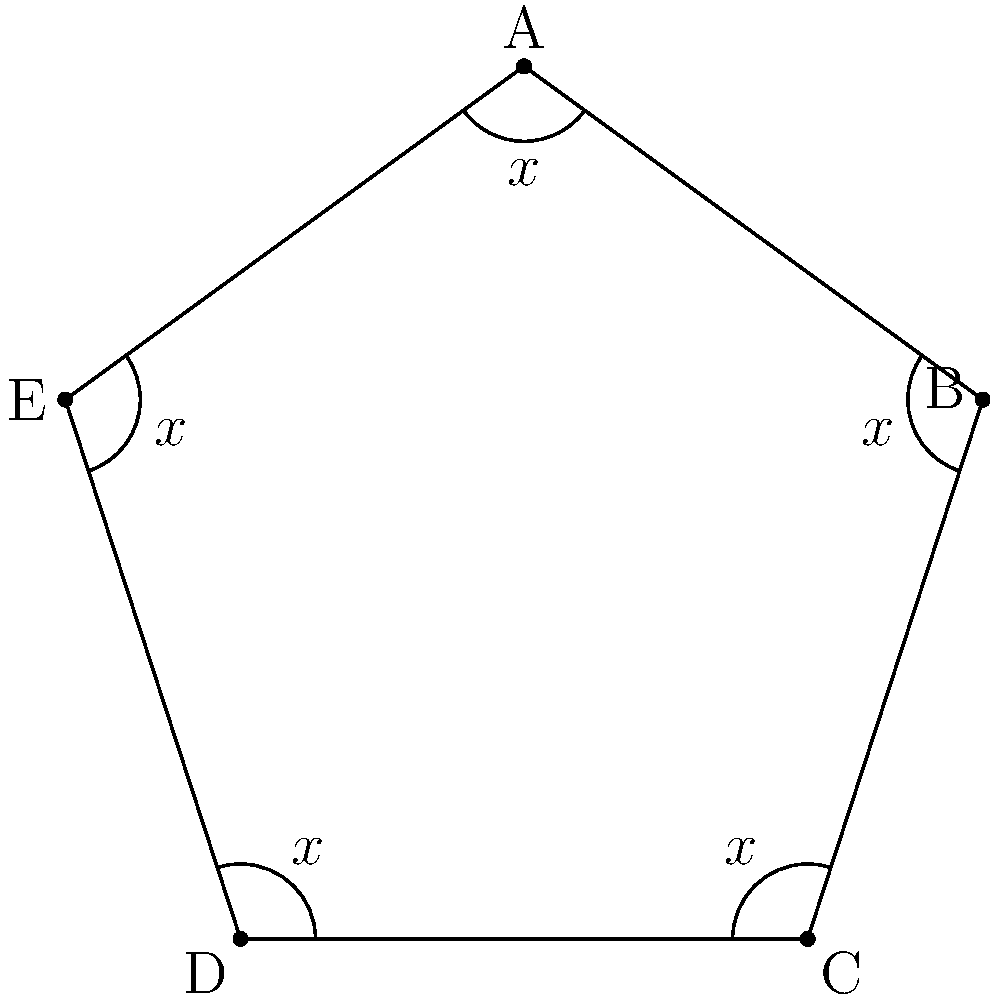In this regular pentagon, all interior angles are marked as $x$. If you were teaching your grandchild about geometry, how would you explain to them how to find the value of $x$ in degrees? To find the value of $x$, let's follow these steps:

1. Recall that the sum of interior angles in any pentagon is $(5-2) \times 180^\circ = 540^\circ$.

2. In a regular pentagon, all interior angles are equal. Let's call each angle $x$.

3. Since there are 5 angles, and they all add up to $540^\circ$, we can write an equation:
   
   $5x = 540^\circ$

4. To solve for $x$, divide both sides by 5:
   
   $x = 540^\circ \div 5 = 108^\circ$

5. Therefore, each interior angle of a regular pentagon measures $108^\circ$.

This approach helps understand the relationship between the number of sides in a polygon and its interior angles, which is a fundamental concept in geometry.
Answer: $108^\circ$ 